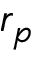<formula> <loc_0><loc_0><loc_500><loc_500>r _ { p }</formula> 